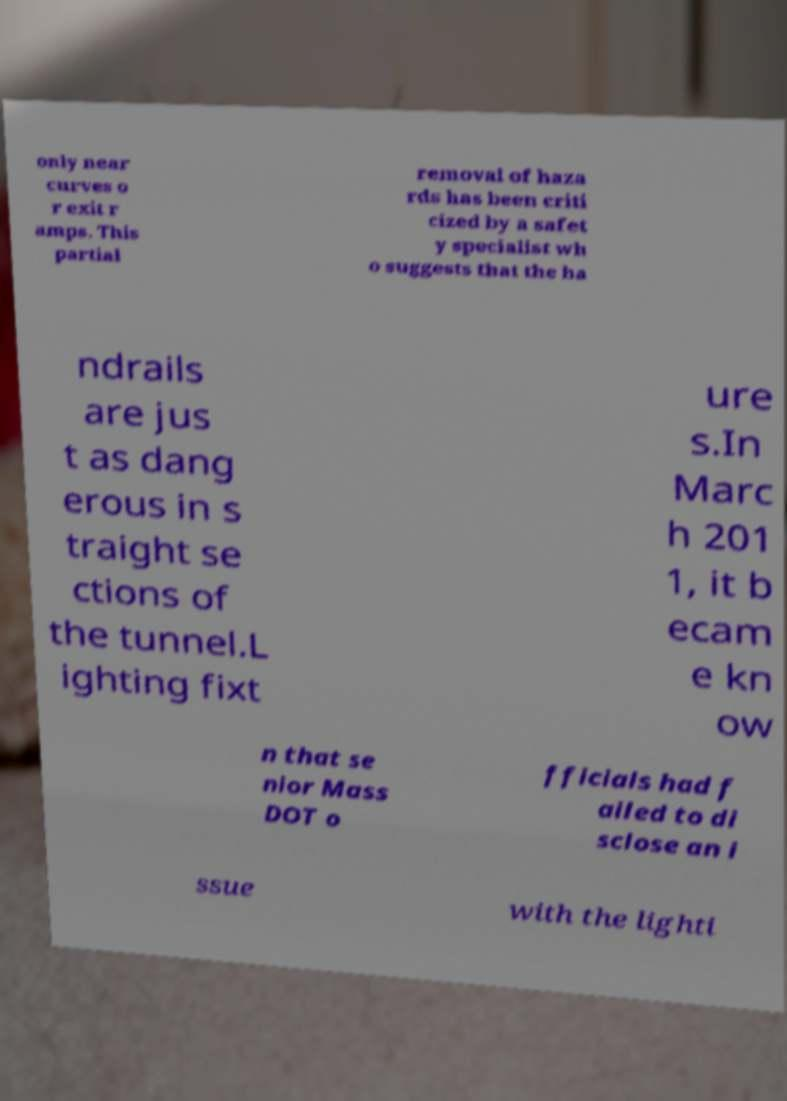Please identify and transcribe the text found in this image. only near curves o r exit r amps. This partial removal of haza rds has been criti cized by a safet y specialist wh o suggests that the ha ndrails are jus t as dang erous in s traight se ctions of the tunnel.L ighting fixt ure s.In Marc h 201 1, it b ecam e kn ow n that se nior Mass DOT o fficials had f ailed to di sclose an i ssue with the lighti 